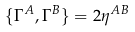Convert formula to latex. <formula><loc_0><loc_0><loc_500><loc_500>\{ \Gamma ^ { A } , \Gamma ^ { B } \} = 2 \eta ^ { A B }</formula> 